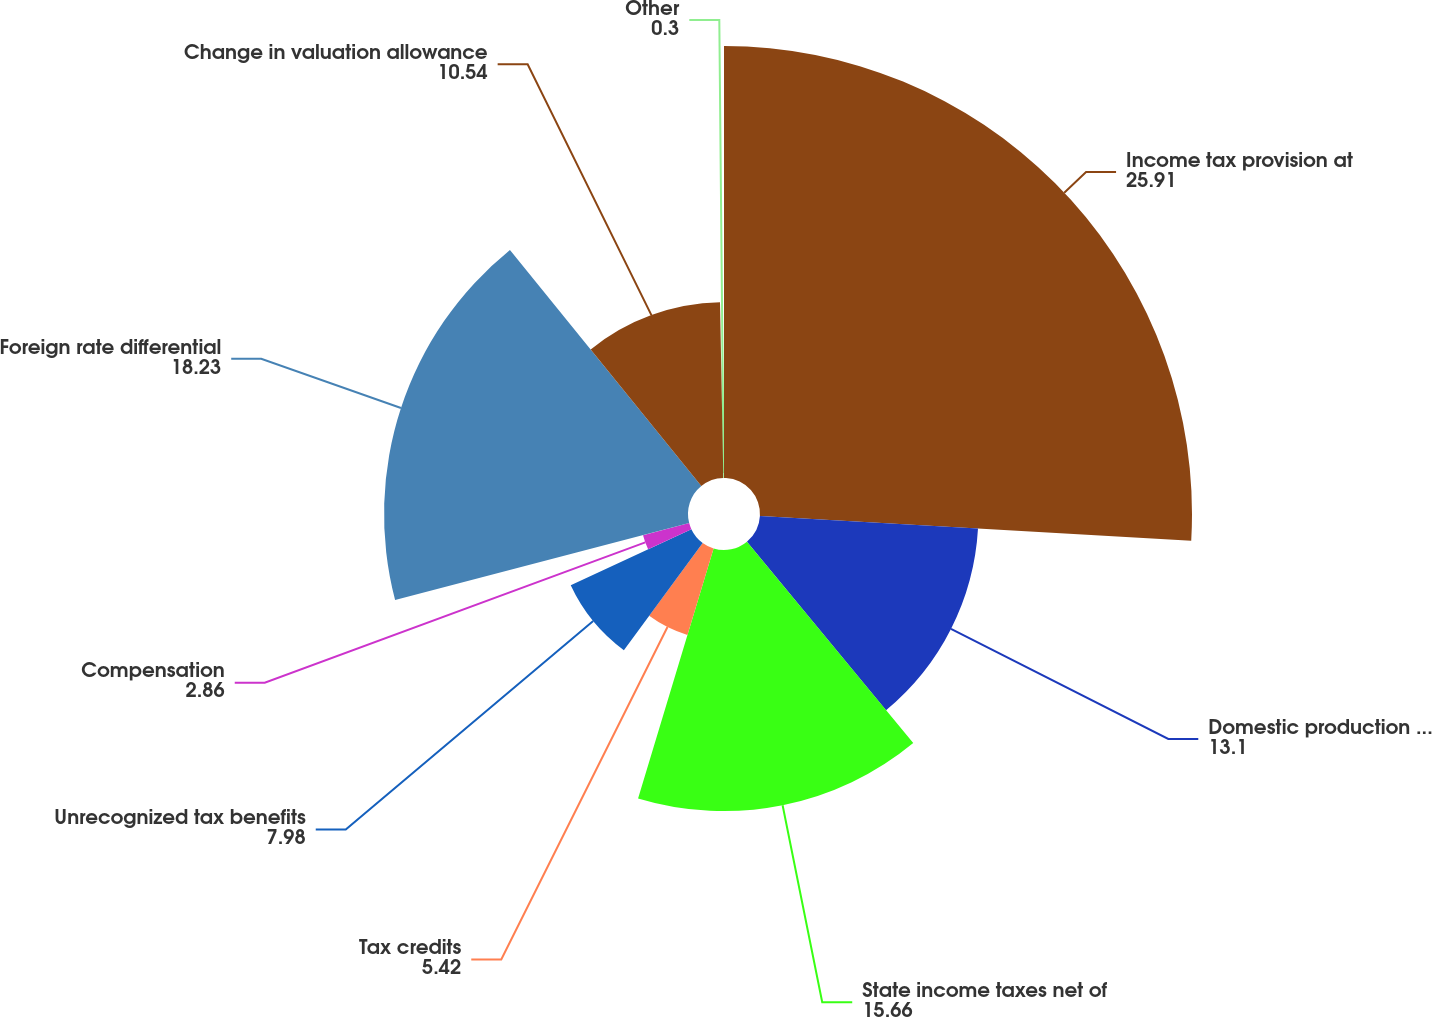Convert chart. <chart><loc_0><loc_0><loc_500><loc_500><pie_chart><fcel>Income tax provision at<fcel>Domestic production activities<fcel>State income taxes net of<fcel>Tax credits<fcel>Unrecognized tax benefits<fcel>Compensation<fcel>Foreign rate differential<fcel>Change in valuation allowance<fcel>Other<nl><fcel>25.91%<fcel>13.1%<fcel>15.66%<fcel>5.42%<fcel>7.98%<fcel>2.86%<fcel>18.23%<fcel>10.54%<fcel>0.3%<nl></chart> 